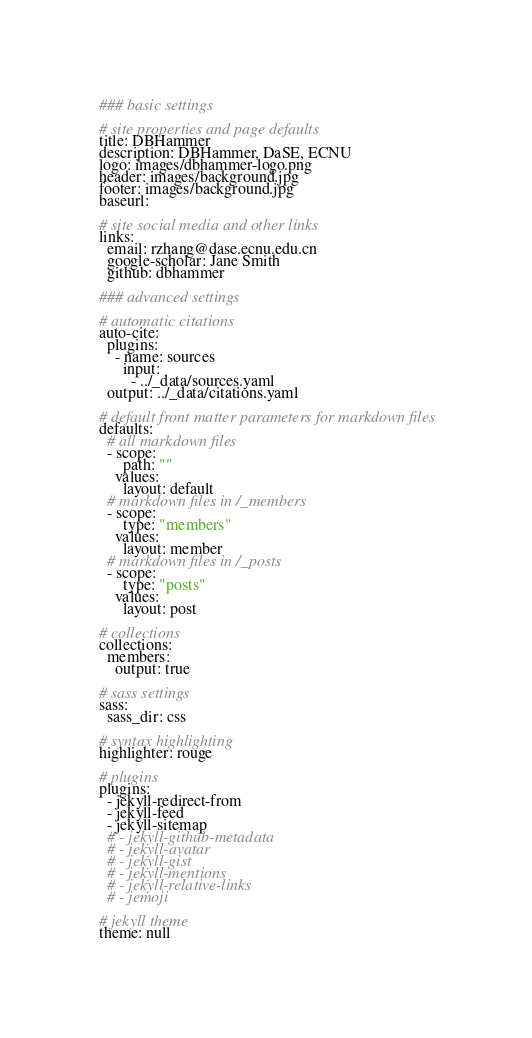Convert code to text. <code><loc_0><loc_0><loc_500><loc_500><_YAML_>### basic settings

# site properties and page defaults
title: DBHammer
description: DBHammer, DaSE, ECNU
logo: images/dbhammer-logo.png
header: images/background.jpg
footer: images/background.jpg
baseurl: 

# site social media and other links
links:
  email: rzhang@dase.ecnu.edu.cn
  google-scholar: Jane Smith
  github: dbhammer

### advanced settings

# automatic citations
auto-cite:
  plugins:
    - name: sources
      input:
        - ../_data/sources.yaml
  output: ../_data/citations.yaml

# default front matter parameters for markdown files
defaults:
  # all markdown files
  - scope:
      path: ""
    values:
      layout: default
  # markdown files in /_members
  - scope:
      type: "members"
    values:
      layout: member
  # markdown files in /_posts
  - scope:
      type: "posts"
    values:
      layout: post

# collections
collections:
  members:
    output: true

# sass settings
sass:
  sass_dir: css

# syntax highlighting
highlighter: rouge

# plugins
plugins:
  - jekyll-redirect-from
  - jekyll-feed
  - jekyll-sitemap
  # - jekyll-github-metadata
  # - jekyll-avatar
  # - jekyll-gist
  # - jekyll-mentions
  # - jekyll-relative-links
  # - jemoji

# jekyll theme
theme: null
</code> 